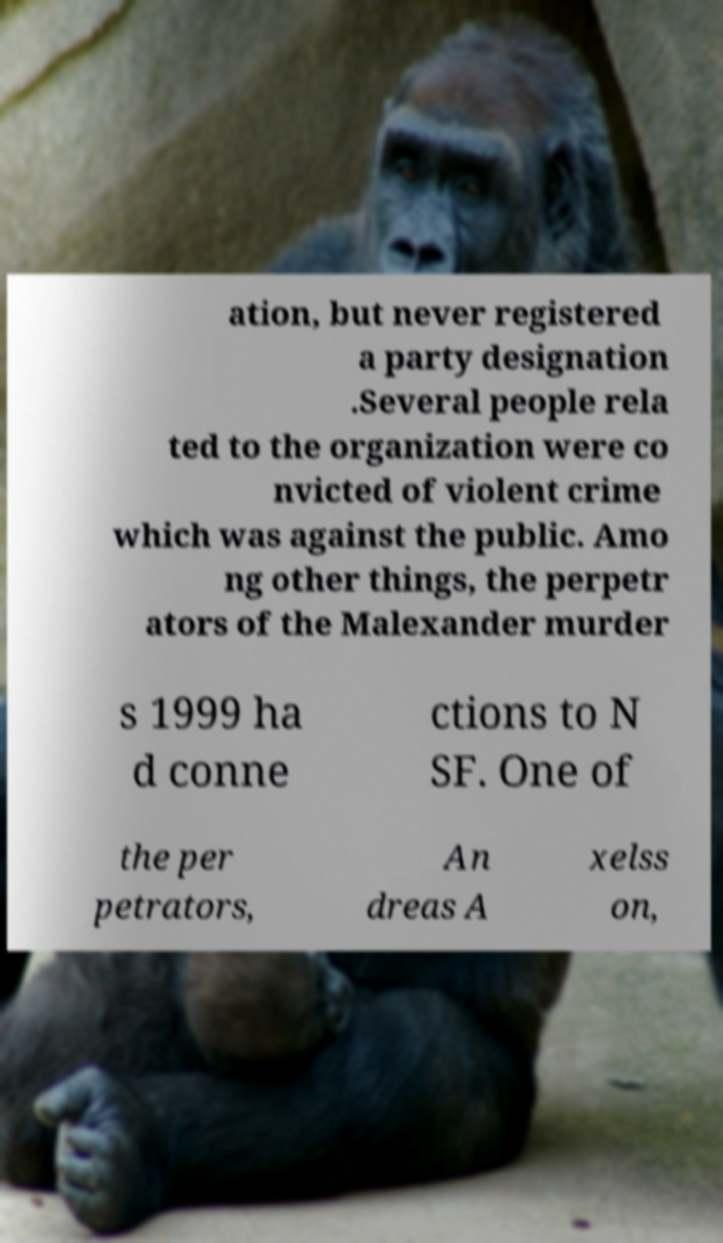Could you extract and type out the text from this image? ation, but never registered a party designation .Several people rela ted to the organization were co nvicted of violent crime which was against the public. Amo ng other things, the perpetr ators of the Malexander murder s 1999 ha d conne ctions to N SF. One of the per petrators, An dreas A xelss on, 